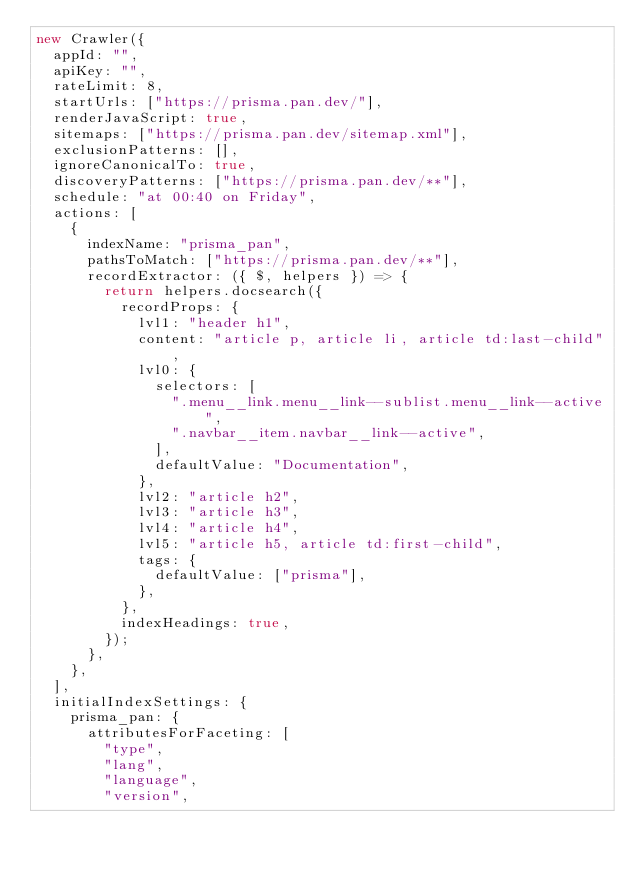<code> <loc_0><loc_0><loc_500><loc_500><_JavaScript_>new Crawler({
  appId: "",
  apiKey: "",
  rateLimit: 8,
  startUrls: ["https://prisma.pan.dev/"],
  renderJavaScript: true,
  sitemaps: ["https://prisma.pan.dev/sitemap.xml"],
  exclusionPatterns: [],
  ignoreCanonicalTo: true,
  discoveryPatterns: ["https://prisma.pan.dev/**"],
  schedule: "at 00:40 on Friday",
  actions: [
    {
      indexName: "prisma_pan",
      pathsToMatch: ["https://prisma.pan.dev/**"],
      recordExtractor: ({ $, helpers }) => {
        return helpers.docsearch({
          recordProps: {
            lvl1: "header h1",
            content: "article p, article li, article td:last-child",
            lvl0: {
              selectors: [
                ".menu__link.menu__link--sublist.menu__link--active",
                ".navbar__item.navbar__link--active",
              ],
              defaultValue: "Documentation",
            },
            lvl2: "article h2",
            lvl3: "article h3",
            lvl4: "article h4",
            lvl5: "article h5, article td:first-child",
            tags: {
              defaultValue: ["prisma"],
            },
          },
          indexHeadings: true,
        });
      },
    },
  ],
  initialIndexSettings: {
    prisma_pan: {
      attributesForFaceting: [
        "type",
        "lang",
        "language",
        "version",</code> 